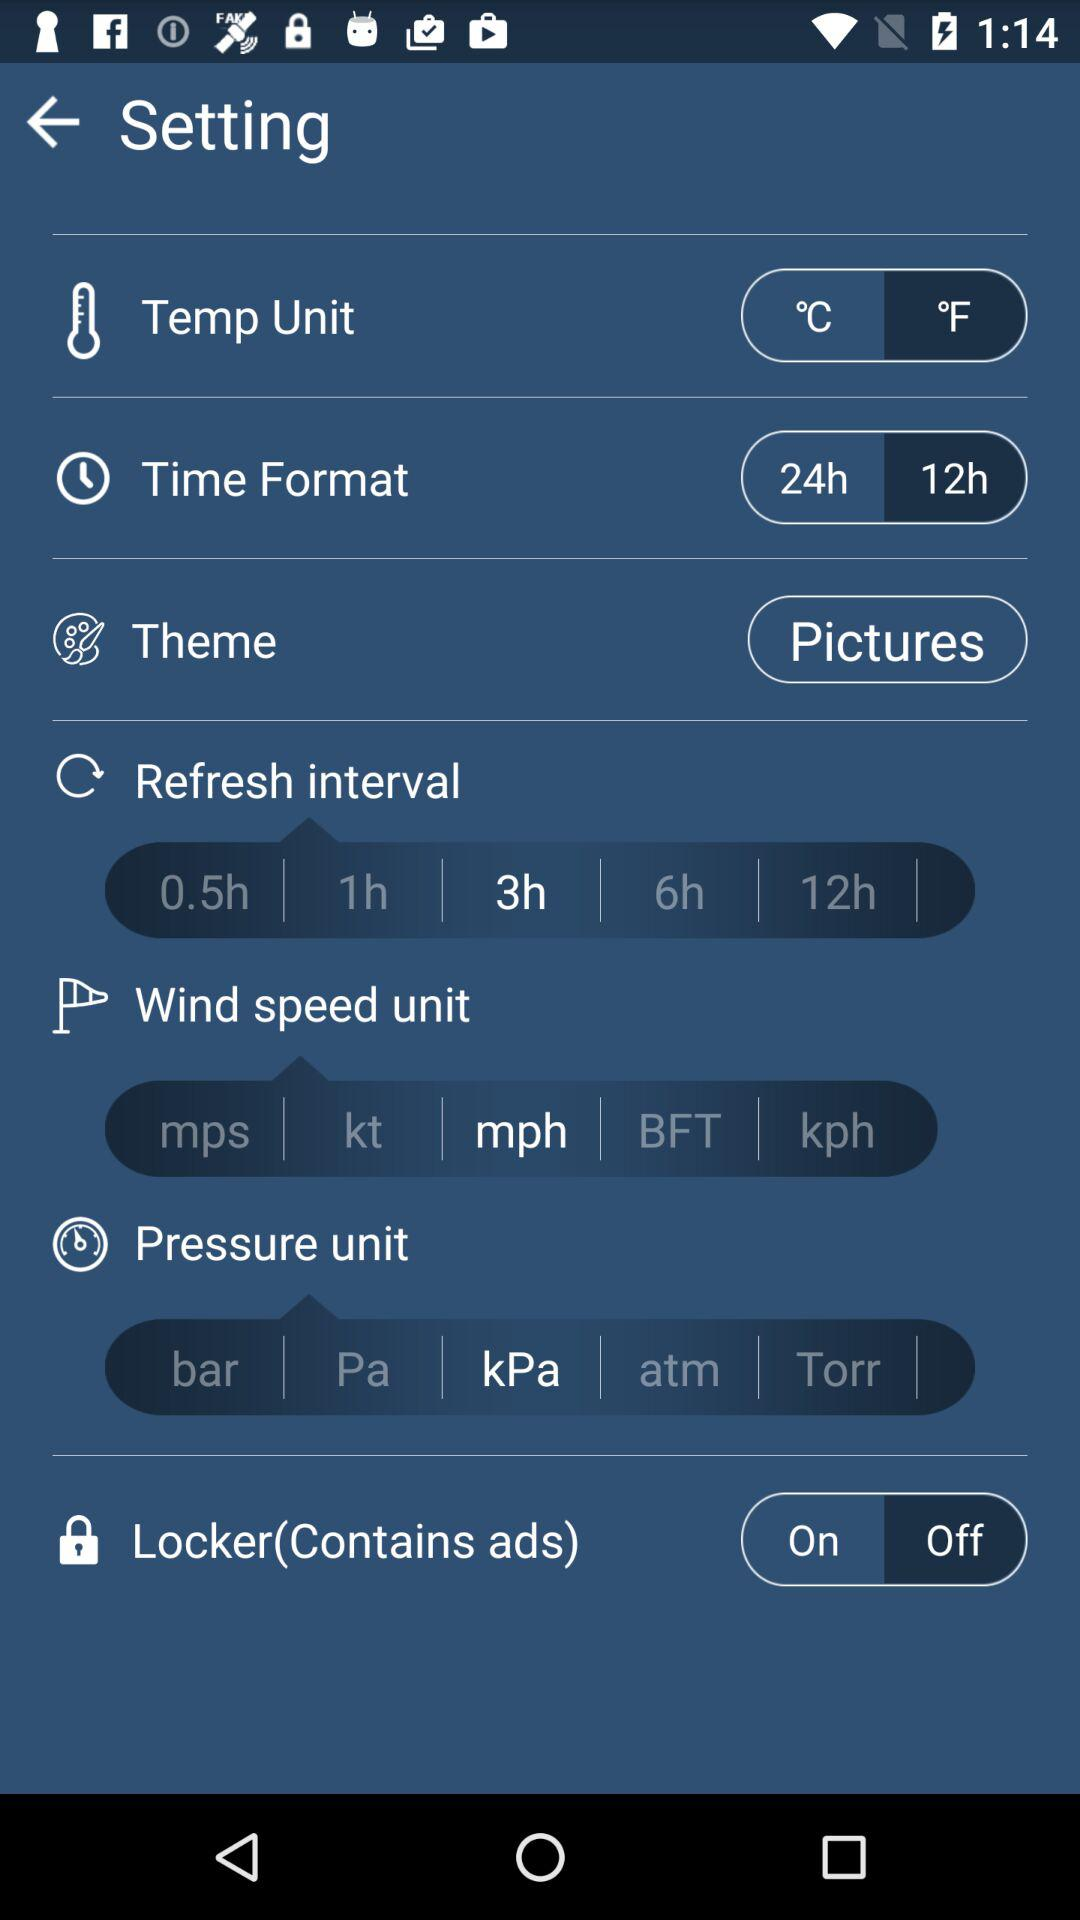What theme is given? The given theme is pictures. 